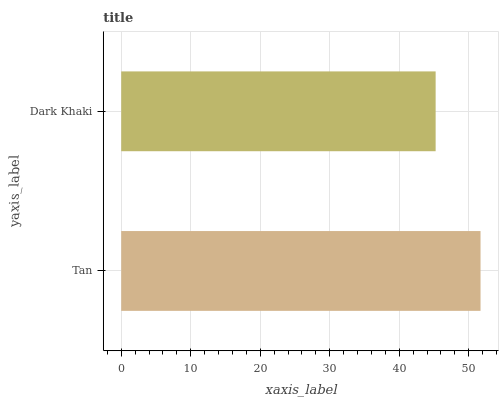Is Dark Khaki the minimum?
Answer yes or no. Yes. Is Tan the maximum?
Answer yes or no. Yes. Is Dark Khaki the maximum?
Answer yes or no. No. Is Tan greater than Dark Khaki?
Answer yes or no. Yes. Is Dark Khaki less than Tan?
Answer yes or no. Yes. Is Dark Khaki greater than Tan?
Answer yes or no. No. Is Tan less than Dark Khaki?
Answer yes or no. No. Is Tan the high median?
Answer yes or no. Yes. Is Dark Khaki the low median?
Answer yes or no. Yes. Is Dark Khaki the high median?
Answer yes or no. No. Is Tan the low median?
Answer yes or no. No. 